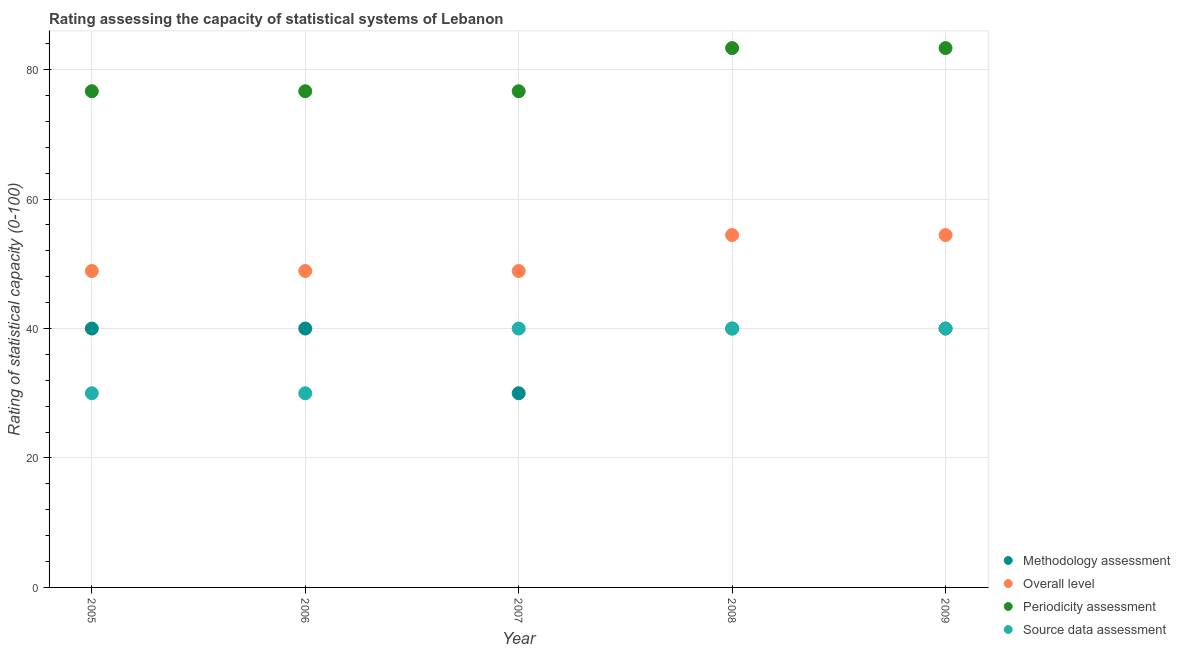How many different coloured dotlines are there?
Your answer should be compact. 4. Is the number of dotlines equal to the number of legend labels?
Your answer should be compact. Yes. What is the overall level rating in 2006?
Your answer should be very brief. 48.89. Across all years, what is the maximum overall level rating?
Offer a very short reply. 54.44. Across all years, what is the minimum methodology assessment rating?
Make the answer very short. 30. In which year was the overall level rating maximum?
Your answer should be very brief. 2008. In which year was the methodology assessment rating minimum?
Keep it short and to the point. 2007. What is the total overall level rating in the graph?
Your answer should be very brief. 255.56. What is the difference between the methodology assessment rating in 2007 and the source data assessment rating in 2009?
Offer a terse response. -10. In the year 2007, what is the difference between the overall level rating and source data assessment rating?
Keep it short and to the point. 8.89. What is the ratio of the periodicity assessment rating in 2007 to that in 2009?
Keep it short and to the point. 0.92. Is the difference between the periodicity assessment rating in 2006 and 2009 greater than the difference between the methodology assessment rating in 2006 and 2009?
Provide a succinct answer. No. What is the difference between the highest and the second highest source data assessment rating?
Your answer should be compact. 0. What is the difference between the highest and the lowest methodology assessment rating?
Provide a succinct answer. 10. Is it the case that in every year, the sum of the overall level rating and source data assessment rating is greater than the sum of methodology assessment rating and periodicity assessment rating?
Your answer should be compact. No. How many dotlines are there?
Offer a terse response. 4. How many years are there in the graph?
Provide a short and direct response. 5. Does the graph contain any zero values?
Your answer should be compact. No. Where does the legend appear in the graph?
Provide a short and direct response. Bottom right. How are the legend labels stacked?
Keep it short and to the point. Vertical. What is the title of the graph?
Ensure brevity in your answer.  Rating assessing the capacity of statistical systems of Lebanon. Does "Social equity" appear as one of the legend labels in the graph?
Ensure brevity in your answer.  No. What is the label or title of the Y-axis?
Ensure brevity in your answer.  Rating of statistical capacity (0-100). What is the Rating of statistical capacity (0-100) in Overall level in 2005?
Keep it short and to the point. 48.89. What is the Rating of statistical capacity (0-100) of Periodicity assessment in 2005?
Your response must be concise. 76.67. What is the Rating of statistical capacity (0-100) of Source data assessment in 2005?
Provide a short and direct response. 30. What is the Rating of statistical capacity (0-100) of Methodology assessment in 2006?
Make the answer very short. 40. What is the Rating of statistical capacity (0-100) in Overall level in 2006?
Ensure brevity in your answer.  48.89. What is the Rating of statistical capacity (0-100) in Periodicity assessment in 2006?
Give a very brief answer. 76.67. What is the Rating of statistical capacity (0-100) of Source data assessment in 2006?
Keep it short and to the point. 30. What is the Rating of statistical capacity (0-100) of Overall level in 2007?
Your response must be concise. 48.89. What is the Rating of statistical capacity (0-100) in Periodicity assessment in 2007?
Offer a terse response. 76.67. What is the Rating of statistical capacity (0-100) of Overall level in 2008?
Give a very brief answer. 54.44. What is the Rating of statistical capacity (0-100) in Periodicity assessment in 2008?
Ensure brevity in your answer.  83.33. What is the Rating of statistical capacity (0-100) of Overall level in 2009?
Make the answer very short. 54.44. What is the Rating of statistical capacity (0-100) of Periodicity assessment in 2009?
Your answer should be very brief. 83.33. What is the Rating of statistical capacity (0-100) of Source data assessment in 2009?
Your answer should be compact. 40. Across all years, what is the maximum Rating of statistical capacity (0-100) in Overall level?
Your response must be concise. 54.44. Across all years, what is the maximum Rating of statistical capacity (0-100) in Periodicity assessment?
Ensure brevity in your answer.  83.33. Across all years, what is the minimum Rating of statistical capacity (0-100) in Methodology assessment?
Your response must be concise. 30. Across all years, what is the minimum Rating of statistical capacity (0-100) in Overall level?
Give a very brief answer. 48.89. Across all years, what is the minimum Rating of statistical capacity (0-100) of Periodicity assessment?
Ensure brevity in your answer.  76.67. Across all years, what is the minimum Rating of statistical capacity (0-100) of Source data assessment?
Offer a terse response. 30. What is the total Rating of statistical capacity (0-100) in Methodology assessment in the graph?
Ensure brevity in your answer.  190. What is the total Rating of statistical capacity (0-100) in Overall level in the graph?
Provide a short and direct response. 255.56. What is the total Rating of statistical capacity (0-100) in Periodicity assessment in the graph?
Your response must be concise. 396.67. What is the total Rating of statistical capacity (0-100) of Source data assessment in the graph?
Ensure brevity in your answer.  180. What is the difference between the Rating of statistical capacity (0-100) of Overall level in 2005 and that in 2006?
Provide a short and direct response. 0. What is the difference between the Rating of statistical capacity (0-100) of Periodicity assessment in 2005 and that in 2006?
Make the answer very short. 0. What is the difference between the Rating of statistical capacity (0-100) in Source data assessment in 2005 and that in 2006?
Give a very brief answer. 0. What is the difference between the Rating of statistical capacity (0-100) of Overall level in 2005 and that in 2007?
Give a very brief answer. 0. What is the difference between the Rating of statistical capacity (0-100) of Source data assessment in 2005 and that in 2007?
Give a very brief answer. -10. What is the difference between the Rating of statistical capacity (0-100) of Overall level in 2005 and that in 2008?
Keep it short and to the point. -5.56. What is the difference between the Rating of statistical capacity (0-100) in Periodicity assessment in 2005 and that in 2008?
Ensure brevity in your answer.  -6.67. What is the difference between the Rating of statistical capacity (0-100) in Source data assessment in 2005 and that in 2008?
Offer a terse response. -10. What is the difference between the Rating of statistical capacity (0-100) of Methodology assessment in 2005 and that in 2009?
Your answer should be very brief. 0. What is the difference between the Rating of statistical capacity (0-100) in Overall level in 2005 and that in 2009?
Provide a short and direct response. -5.56. What is the difference between the Rating of statistical capacity (0-100) in Periodicity assessment in 2005 and that in 2009?
Ensure brevity in your answer.  -6.67. What is the difference between the Rating of statistical capacity (0-100) in Methodology assessment in 2006 and that in 2008?
Offer a terse response. 0. What is the difference between the Rating of statistical capacity (0-100) of Overall level in 2006 and that in 2008?
Keep it short and to the point. -5.56. What is the difference between the Rating of statistical capacity (0-100) in Periodicity assessment in 2006 and that in 2008?
Offer a very short reply. -6.67. What is the difference between the Rating of statistical capacity (0-100) in Overall level in 2006 and that in 2009?
Provide a succinct answer. -5.56. What is the difference between the Rating of statistical capacity (0-100) in Periodicity assessment in 2006 and that in 2009?
Provide a short and direct response. -6.67. What is the difference between the Rating of statistical capacity (0-100) in Source data assessment in 2006 and that in 2009?
Offer a terse response. -10. What is the difference between the Rating of statistical capacity (0-100) in Methodology assessment in 2007 and that in 2008?
Offer a terse response. -10. What is the difference between the Rating of statistical capacity (0-100) of Overall level in 2007 and that in 2008?
Your answer should be very brief. -5.56. What is the difference between the Rating of statistical capacity (0-100) in Periodicity assessment in 2007 and that in 2008?
Keep it short and to the point. -6.67. What is the difference between the Rating of statistical capacity (0-100) of Overall level in 2007 and that in 2009?
Keep it short and to the point. -5.56. What is the difference between the Rating of statistical capacity (0-100) of Periodicity assessment in 2007 and that in 2009?
Give a very brief answer. -6.67. What is the difference between the Rating of statistical capacity (0-100) of Source data assessment in 2007 and that in 2009?
Provide a succinct answer. 0. What is the difference between the Rating of statistical capacity (0-100) in Overall level in 2008 and that in 2009?
Give a very brief answer. 0. What is the difference between the Rating of statistical capacity (0-100) of Source data assessment in 2008 and that in 2009?
Your answer should be very brief. 0. What is the difference between the Rating of statistical capacity (0-100) in Methodology assessment in 2005 and the Rating of statistical capacity (0-100) in Overall level in 2006?
Ensure brevity in your answer.  -8.89. What is the difference between the Rating of statistical capacity (0-100) of Methodology assessment in 2005 and the Rating of statistical capacity (0-100) of Periodicity assessment in 2006?
Your answer should be compact. -36.67. What is the difference between the Rating of statistical capacity (0-100) of Overall level in 2005 and the Rating of statistical capacity (0-100) of Periodicity assessment in 2006?
Offer a terse response. -27.78. What is the difference between the Rating of statistical capacity (0-100) in Overall level in 2005 and the Rating of statistical capacity (0-100) in Source data assessment in 2006?
Give a very brief answer. 18.89. What is the difference between the Rating of statistical capacity (0-100) of Periodicity assessment in 2005 and the Rating of statistical capacity (0-100) of Source data assessment in 2006?
Your response must be concise. 46.67. What is the difference between the Rating of statistical capacity (0-100) in Methodology assessment in 2005 and the Rating of statistical capacity (0-100) in Overall level in 2007?
Keep it short and to the point. -8.89. What is the difference between the Rating of statistical capacity (0-100) of Methodology assessment in 2005 and the Rating of statistical capacity (0-100) of Periodicity assessment in 2007?
Ensure brevity in your answer.  -36.67. What is the difference between the Rating of statistical capacity (0-100) in Methodology assessment in 2005 and the Rating of statistical capacity (0-100) in Source data assessment in 2007?
Give a very brief answer. 0. What is the difference between the Rating of statistical capacity (0-100) of Overall level in 2005 and the Rating of statistical capacity (0-100) of Periodicity assessment in 2007?
Keep it short and to the point. -27.78. What is the difference between the Rating of statistical capacity (0-100) in Overall level in 2005 and the Rating of statistical capacity (0-100) in Source data assessment in 2007?
Offer a terse response. 8.89. What is the difference between the Rating of statistical capacity (0-100) of Periodicity assessment in 2005 and the Rating of statistical capacity (0-100) of Source data assessment in 2007?
Your answer should be very brief. 36.67. What is the difference between the Rating of statistical capacity (0-100) in Methodology assessment in 2005 and the Rating of statistical capacity (0-100) in Overall level in 2008?
Your answer should be very brief. -14.44. What is the difference between the Rating of statistical capacity (0-100) of Methodology assessment in 2005 and the Rating of statistical capacity (0-100) of Periodicity assessment in 2008?
Your answer should be very brief. -43.33. What is the difference between the Rating of statistical capacity (0-100) in Overall level in 2005 and the Rating of statistical capacity (0-100) in Periodicity assessment in 2008?
Offer a terse response. -34.44. What is the difference between the Rating of statistical capacity (0-100) in Overall level in 2005 and the Rating of statistical capacity (0-100) in Source data assessment in 2008?
Your answer should be compact. 8.89. What is the difference between the Rating of statistical capacity (0-100) of Periodicity assessment in 2005 and the Rating of statistical capacity (0-100) of Source data assessment in 2008?
Your answer should be compact. 36.67. What is the difference between the Rating of statistical capacity (0-100) in Methodology assessment in 2005 and the Rating of statistical capacity (0-100) in Overall level in 2009?
Provide a succinct answer. -14.44. What is the difference between the Rating of statistical capacity (0-100) of Methodology assessment in 2005 and the Rating of statistical capacity (0-100) of Periodicity assessment in 2009?
Your answer should be compact. -43.33. What is the difference between the Rating of statistical capacity (0-100) in Overall level in 2005 and the Rating of statistical capacity (0-100) in Periodicity assessment in 2009?
Offer a very short reply. -34.44. What is the difference between the Rating of statistical capacity (0-100) of Overall level in 2005 and the Rating of statistical capacity (0-100) of Source data assessment in 2009?
Provide a short and direct response. 8.89. What is the difference between the Rating of statistical capacity (0-100) of Periodicity assessment in 2005 and the Rating of statistical capacity (0-100) of Source data assessment in 2009?
Provide a succinct answer. 36.67. What is the difference between the Rating of statistical capacity (0-100) of Methodology assessment in 2006 and the Rating of statistical capacity (0-100) of Overall level in 2007?
Your response must be concise. -8.89. What is the difference between the Rating of statistical capacity (0-100) of Methodology assessment in 2006 and the Rating of statistical capacity (0-100) of Periodicity assessment in 2007?
Your response must be concise. -36.67. What is the difference between the Rating of statistical capacity (0-100) in Methodology assessment in 2006 and the Rating of statistical capacity (0-100) in Source data assessment in 2007?
Give a very brief answer. 0. What is the difference between the Rating of statistical capacity (0-100) in Overall level in 2006 and the Rating of statistical capacity (0-100) in Periodicity assessment in 2007?
Keep it short and to the point. -27.78. What is the difference between the Rating of statistical capacity (0-100) in Overall level in 2006 and the Rating of statistical capacity (0-100) in Source data assessment in 2007?
Your answer should be compact. 8.89. What is the difference between the Rating of statistical capacity (0-100) of Periodicity assessment in 2006 and the Rating of statistical capacity (0-100) of Source data assessment in 2007?
Make the answer very short. 36.67. What is the difference between the Rating of statistical capacity (0-100) in Methodology assessment in 2006 and the Rating of statistical capacity (0-100) in Overall level in 2008?
Keep it short and to the point. -14.44. What is the difference between the Rating of statistical capacity (0-100) in Methodology assessment in 2006 and the Rating of statistical capacity (0-100) in Periodicity assessment in 2008?
Your response must be concise. -43.33. What is the difference between the Rating of statistical capacity (0-100) of Overall level in 2006 and the Rating of statistical capacity (0-100) of Periodicity assessment in 2008?
Make the answer very short. -34.44. What is the difference between the Rating of statistical capacity (0-100) of Overall level in 2006 and the Rating of statistical capacity (0-100) of Source data assessment in 2008?
Your answer should be compact. 8.89. What is the difference between the Rating of statistical capacity (0-100) in Periodicity assessment in 2006 and the Rating of statistical capacity (0-100) in Source data assessment in 2008?
Your answer should be compact. 36.67. What is the difference between the Rating of statistical capacity (0-100) in Methodology assessment in 2006 and the Rating of statistical capacity (0-100) in Overall level in 2009?
Your answer should be very brief. -14.44. What is the difference between the Rating of statistical capacity (0-100) in Methodology assessment in 2006 and the Rating of statistical capacity (0-100) in Periodicity assessment in 2009?
Keep it short and to the point. -43.33. What is the difference between the Rating of statistical capacity (0-100) in Overall level in 2006 and the Rating of statistical capacity (0-100) in Periodicity assessment in 2009?
Provide a succinct answer. -34.44. What is the difference between the Rating of statistical capacity (0-100) in Overall level in 2006 and the Rating of statistical capacity (0-100) in Source data assessment in 2009?
Your answer should be very brief. 8.89. What is the difference between the Rating of statistical capacity (0-100) of Periodicity assessment in 2006 and the Rating of statistical capacity (0-100) of Source data assessment in 2009?
Provide a short and direct response. 36.67. What is the difference between the Rating of statistical capacity (0-100) in Methodology assessment in 2007 and the Rating of statistical capacity (0-100) in Overall level in 2008?
Provide a succinct answer. -24.44. What is the difference between the Rating of statistical capacity (0-100) of Methodology assessment in 2007 and the Rating of statistical capacity (0-100) of Periodicity assessment in 2008?
Your response must be concise. -53.33. What is the difference between the Rating of statistical capacity (0-100) in Methodology assessment in 2007 and the Rating of statistical capacity (0-100) in Source data assessment in 2008?
Provide a short and direct response. -10. What is the difference between the Rating of statistical capacity (0-100) of Overall level in 2007 and the Rating of statistical capacity (0-100) of Periodicity assessment in 2008?
Provide a succinct answer. -34.44. What is the difference between the Rating of statistical capacity (0-100) of Overall level in 2007 and the Rating of statistical capacity (0-100) of Source data assessment in 2008?
Give a very brief answer. 8.89. What is the difference between the Rating of statistical capacity (0-100) in Periodicity assessment in 2007 and the Rating of statistical capacity (0-100) in Source data assessment in 2008?
Ensure brevity in your answer.  36.67. What is the difference between the Rating of statistical capacity (0-100) in Methodology assessment in 2007 and the Rating of statistical capacity (0-100) in Overall level in 2009?
Your answer should be very brief. -24.44. What is the difference between the Rating of statistical capacity (0-100) in Methodology assessment in 2007 and the Rating of statistical capacity (0-100) in Periodicity assessment in 2009?
Offer a terse response. -53.33. What is the difference between the Rating of statistical capacity (0-100) in Methodology assessment in 2007 and the Rating of statistical capacity (0-100) in Source data assessment in 2009?
Ensure brevity in your answer.  -10. What is the difference between the Rating of statistical capacity (0-100) of Overall level in 2007 and the Rating of statistical capacity (0-100) of Periodicity assessment in 2009?
Your answer should be compact. -34.44. What is the difference between the Rating of statistical capacity (0-100) in Overall level in 2007 and the Rating of statistical capacity (0-100) in Source data assessment in 2009?
Offer a terse response. 8.89. What is the difference between the Rating of statistical capacity (0-100) of Periodicity assessment in 2007 and the Rating of statistical capacity (0-100) of Source data assessment in 2009?
Keep it short and to the point. 36.67. What is the difference between the Rating of statistical capacity (0-100) in Methodology assessment in 2008 and the Rating of statistical capacity (0-100) in Overall level in 2009?
Your response must be concise. -14.44. What is the difference between the Rating of statistical capacity (0-100) in Methodology assessment in 2008 and the Rating of statistical capacity (0-100) in Periodicity assessment in 2009?
Your answer should be compact. -43.33. What is the difference between the Rating of statistical capacity (0-100) of Overall level in 2008 and the Rating of statistical capacity (0-100) of Periodicity assessment in 2009?
Offer a terse response. -28.89. What is the difference between the Rating of statistical capacity (0-100) in Overall level in 2008 and the Rating of statistical capacity (0-100) in Source data assessment in 2009?
Offer a very short reply. 14.44. What is the difference between the Rating of statistical capacity (0-100) in Periodicity assessment in 2008 and the Rating of statistical capacity (0-100) in Source data assessment in 2009?
Your answer should be compact. 43.33. What is the average Rating of statistical capacity (0-100) of Methodology assessment per year?
Offer a terse response. 38. What is the average Rating of statistical capacity (0-100) in Overall level per year?
Offer a very short reply. 51.11. What is the average Rating of statistical capacity (0-100) of Periodicity assessment per year?
Give a very brief answer. 79.33. In the year 2005, what is the difference between the Rating of statistical capacity (0-100) of Methodology assessment and Rating of statistical capacity (0-100) of Overall level?
Ensure brevity in your answer.  -8.89. In the year 2005, what is the difference between the Rating of statistical capacity (0-100) of Methodology assessment and Rating of statistical capacity (0-100) of Periodicity assessment?
Provide a succinct answer. -36.67. In the year 2005, what is the difference between the Rating of statistical capacity (0-100) of Methodology assessment and Rating of statistical capacity (0-100) of Source data assessment?
Offer a very short reply. 10. In the year 2005, what is the difference between the Rating of statistical capacity (0-100) in Overall level and Rating of statistical capacity (0-100) in Periodicity assessment?
Offer a very short reply. -27.78. In the year 2005, what is the difference between the Rating of statistical capacity (0-100) of Overall level and Rating of statistical capacity (0-100) of Source data assessment?
Offer a terse response. 18.89. In the year 2005, what is the difference between the Rating of statistical capacity (0-100) in Periodicity assessment and Rating of statistical capacity (0-100) in Source data assessment?
Your answer should be compact. 46.67. In the year 2006, what is the difference between the Rating of statistical capacity (0-100) of Methodology assessment and Rating of statistical capacity (0-100) of Overall level?
Offer a terse response. -8.89. In the year 2006, what is the difference between the Rating of statistical capacity (0-100) in Methodology assessment and Rating of statistical capacity (0-100) in Periodicity assessment?
Give a very brief answer. -36.67. In the year 2006, what is the difference between the Rating of statistical capacity (0-100) of Methodology assessment and Rating of statistical capacity (0-100) of Source data assessment?
Offer a terse response. 10. In the year 2006, what is the difference between the Rating of statistical capacity (0-100) of Overall level and Rating of statistical capacity (0-100) of Periodicity assessment?
Provide a succinct answer. -27.78. In the year 2006, what is the difference between the Rating of statistical capacity (0-100) of Overall level and Rating of statistical capacity (0-100) of Source data assessment?
Keep it short and to the point. 18.89. In the year 2006, what is the difference between the Rating of statistical capacity (0-100) in Periodicity assessment and Rating of statistical capacity (0-100) in Source data assessment?
Offer a very short reply. 46.67. In the year 2007, what is the difference between the Rating of statistical capacity (0-100) in Methodology assessment and Rating of statistical capacity (0-100) in Overall level?
Ensure brevity in your answer.  -18.89. In the year 2007, what is the difference between the Rating of statistical capacity (0-100) in Methodology assessment and Rating of statistical capacity (0-100) in Periodicity assessment?
Your response must be concise. -46.67. In the year 2007, what is the difference between the Rating of statistical capacity (0-100) in Overall level and Rating of statistical capacity (0-100) in Periodicity assessment?
Make the answer very short. -27.78. In the year 2007, what is the difference between the Rating of statistical capacity (0-100) in Overall level and Rating of statistical capacity (0-100) in Source data assessment?
Offer a very short reply. 8.89. In the year 2007, what is the difference between the Rating of statistical capacity (0-100) of Periodicity assessment and Rating of statistical capacity (0-100) of Source data assessment?
Make the answer very short. 36.67. In the year 2008, what is the difference between the Rating of statistical capacity (0-100) in Methodology assessment and Rating of statistical capacity (0-100) in Overall level?
Your answer should be compact. -14.44. In the year 2008, what is the difference between the Rating of statistical capacity (0-100) of Methodology assessment and Rating of statistical capacity (0-100) of Periodicity assessment?
Ensure brevity in your answer.  -43.33. In the year 2008, what is the difference between the Rating of statistical capacity (0-100) of Overall level and Rating of statistical capacity (0-100) of Periodicity assessment?
Your answer should be very brief. -28.89. In the year 2008, what is the difference between the Rating of statistical capacity (0-100) in Overall level and Rating of statistical capacity (0-100) in Source data assessment?
Make the answer very short. 14.44. In the year 2008, what is the difference between the Rating of statistical capacity (0-100) of Periodicity assessment and Rating of statistical capacity (0-100) of Source data assessment?
Keep it short and to the point. 43.33. In the year 2009, what is the difference between the Rating of statistical capacity (0-100) in Methodology assessment and Rating of statistical capacity (0-100) in Overall level?
Give a very brief answer. -14.44. In the year 2009, what is the difference between the Rating of statistical capacity (0-100) of Methodology assessment and Rating of statistical capacity (0-100) of Periodicity assessment?
Offer a very short reply. -43.33. In the year 2009, what is the difference between the Rating of statistical capacity (0-100) in Overall level and Rating of statistical capacity (0-100) in Periodicity assessment?
Ensure brevity in your answer.  -28.89. In the year 2009, what is the difference between the Rating of statistical capacity (0-100) in Overall level and Rating of statistical capacity (0-100) in Source data assessment?
Provide a short and direct response. 14.44. In the year 2009, what is the difference between the Rating of statistical capacity (0-100) of Periodicity assessment and Rating of statistical capacity (0-100) of Source data assessment?
Give a very brief answer. 43.33. What is the ratio of the Rating of statistical capacity (0-100) in Overall level in 2005 to that in 2006?
Offer a terse response. 1. What is the ratio of the Rating of statistical capacity (0-100) in Source data assessment in 2005 to that in 2006?
Give a very brief answer. 1. What is the ratio of the Rating of statistical capacity (0-100) of Overall level in 2005 to that in 2007?
Make the answer very short. 1. What is the ratio of the Rating of statistical capacity (0-100) in Source data assessment in 2005 to that in 2007?
Offer a very short reply. 0.75. What is the ratio of the Rating of statistical capacity (0-100) in Methodology assessment in 2005 to that in 2008?
Provide a succinct answer. 1. What is the ratio of the Rating of statistical capacity (0-100) of Overall level in 2005 to that in 2008?
Give a very brief answer. 0.9. What is the ratio of the Rating of statistical capacity (0-100) in Periodicity assessment in 2005 to that in 2008?
Your answer should be very brief. 0.92. What is the ratio of the Rating of statistical capacity (0-100) in Source data assessment in 2005 to that in 2008?
Offer a terse response. 0.75. What is the ratio of the Rating of statistical capacity (0-100) in Overall level in 2005 to that in 2009?
Provide a short and direct response. 0.9. What is the ratio of the Rating of statistical capacity (0-100) of Periodicity assessment in 2005 to that in 2009?
Provide a short and direct response. 0.92. What is the ratio of the Rating of statistical capacity (0-100) in Source data assessment in 2005 to that in 2009?
Provide a short and direct response. 0.75. What is the ratio of the Rating of statistical capacity (0-100) in Overall level in 2006 to that in 2007?
Ensure brevity in your answer.  1. What is the ratio of the Rating of statistical capacity (0-100) in Periodicity assessment in 2006 to that in 2007?
Your answer should be very brief. 1. What is the ratio of the Rating of statistical capacity (0-100) in Source data assessment in 2006 to that in 2007?
Your answer should be compact. 0.75. What is the ratio of the Rating of statistical capacity (0-100) in Methodology assessment in 2006 to that in 2008?
Ensure brevity in your answer.  1. What is the ratio of the Rating of statistical capacity (0-100) in Overall level in 2006 to that in 2008?
Provide a succinct answer. 0.9. What is the ratio of the Rating of statistical capacity (0-100) of Overall level in 2006 to that in 2009?
Your answer should be very brief. 0.9. What is the ratio of the Rating of statistical capacity (0-100) in Methodology assessment in 2007 to that in 2008?
Offer a terse response. 0.75. What is the ratio of the Rating of statistical capacity (0-100) of Overall level in 2007 to that in 2008?
Your answer should be compact. 0.9. What is the ratio of the Rating of statistical capacity (0-100) of Source data assessment in 2007 to that in 2008?
Your response must be concise. 1. What is the ratio of the Rating of statistical capacity (0-100) of Overall level in 2007 to that in 2009?
Your response must be concise. 0.9. What is the ratio of the Rating of statistical capacity (0-100) in Periodicity assessment in 2007 to that in 2009?
Your answer should be very brief. 0.92. What is the ratio of the Rating of statistical capacity (0-100) of Source data assessment in 2007 to that in 2009?
Offer a very short reply. 1. What is the ratio of the Rating of statistical capacity (0-100) in Overall level in 2008 to that in 2009?
Your answer should be compact. 1. What is the difference between the highest and the second highest Rating of statistical capacity (0-100) of Overall level?
Give a very brief answer. 0. What is the difference between the highest and the second highest Rating of statistical capacity (0-100) in Periodicity assessment?
Your answer should be compact. 0. What is the difference between the highest and the second highest Rating of statistical capacity (0-100) of Source data assessment?
Offer a very short reply. 0. What is the difference between the highest and the lowest Rating of statistical capacity (0-100) in Overall level?
Make the answer very short. 5.56. 